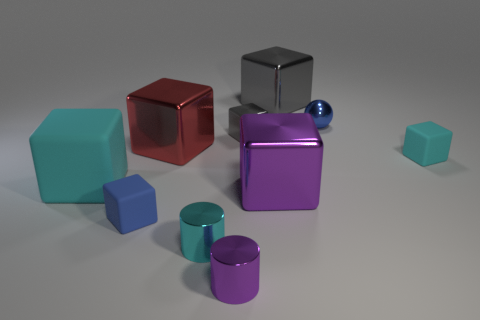There is a thing that is the same color as the small shiny ball; what material is it?
Your answer should be compact. Rubber. How many objects are either big objects that are on the right side of the large cyan matte thing or large rubber objects?
Your answer should be very brief. 4. How many other things are there of the same shape as the big purple shiny object?
Ensure brevity in your answer.  6. Is the number of cyan rubber things that are on the left side of the blue metallic object greater than the number of spheres?
Offer a terse response. No. The blue matte thing that is the same shape as the small cyan matte thing is what size?
Offer a very short reply. Small. Is there anything else that is made of the same material as the tiny cyan cylinder?
Keep it short and to the point. Yes. What is the shape of the large purple object?
Keep it short and to the point. Cube. There is a blue shiny object that is the same size as the blue matte cube; what shape is it?
Your answer should be very brief. Sphere. Is there any other thing of the same color as the large rubber object?
Your answer should be compact. Yes. There is a ball that is made of the same material as the tiny purple object; what is its size?
Offer a terse response. Small. 